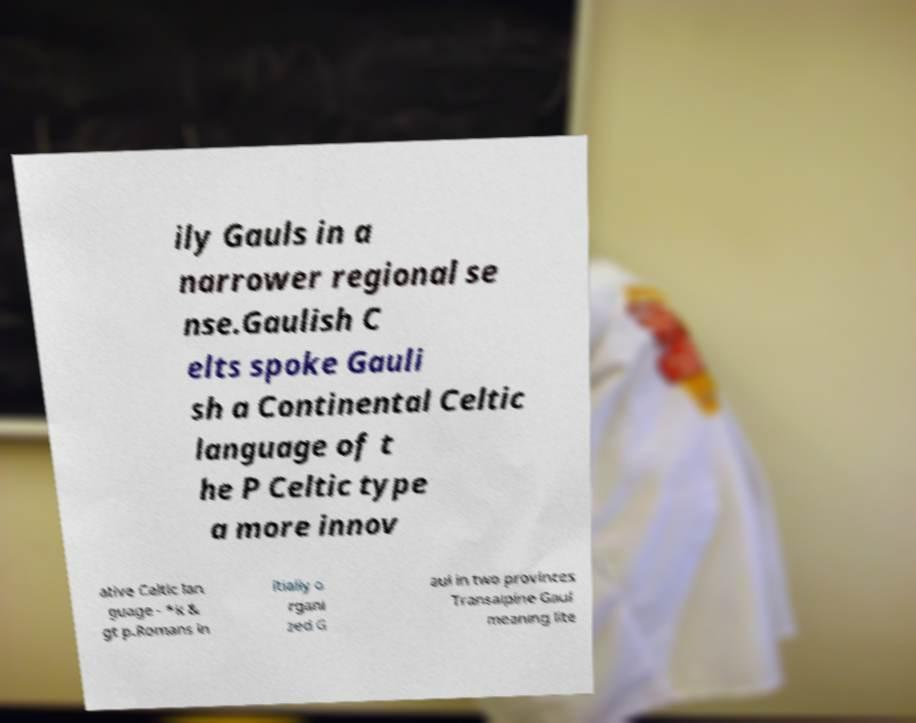Please identify and transcribe the text found in this image. ily Gauls in a narrower regional se nse.Gaulish C elts spoke Gauli sh a Continental Celtic language of t he P Celtic type a more innov ative Celtic lan guage - *k & gt p.Romans in itially o rgani zed G aul in two provinces Transalpine Gaul meaning lite 